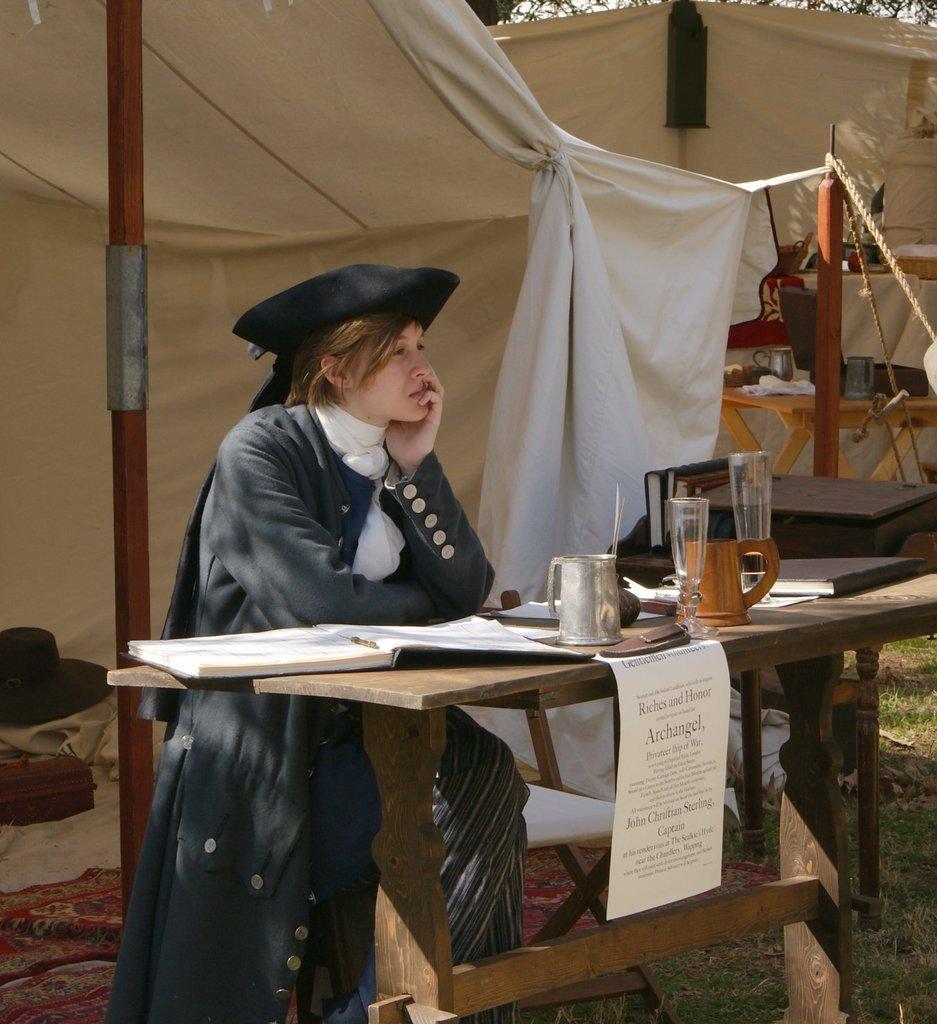Please provide a concise description of this image. In this image there is a woman sitting in chair near the table , and in table there is a jug , glass , paper, book and in back ground there is a tent , tree, hat. 